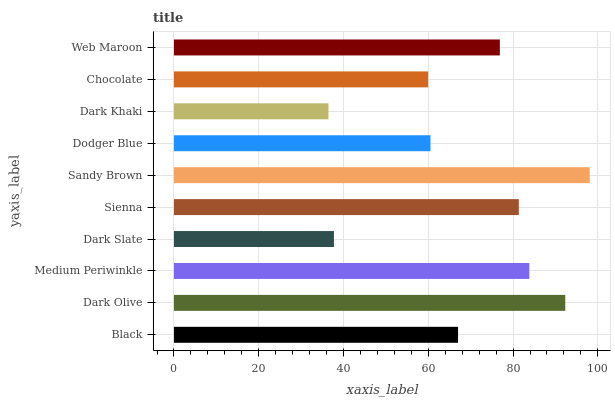Is Dark Khaki the minimum?
Answer yes or no. Yes. Is Sandy Brown the maximum?
Answer yes or no. Yes. Is Dark Olive the minimum?
Answer yes or no. No. Is Dark Olive the maximum?
Answer yes or no. No. Is Dark Olive greater than Black?
Answer yes or no. Yes. Is Black less than Dark Olive?
Answer yes or no. Yes. Is Black greater than Dark Olive?
Answer yes or no. No. Is Dark Olive less than Black?
Answer yes or no. No. Is Web Maroon the high median?
Answer yes or no. Yes. Is Black the low median?
Answer yes or no. Yes. Is Dark Khaki the high median?
Answer yes or no. No. Is Dodger Blue the low median?
Answer yes or no. No. 